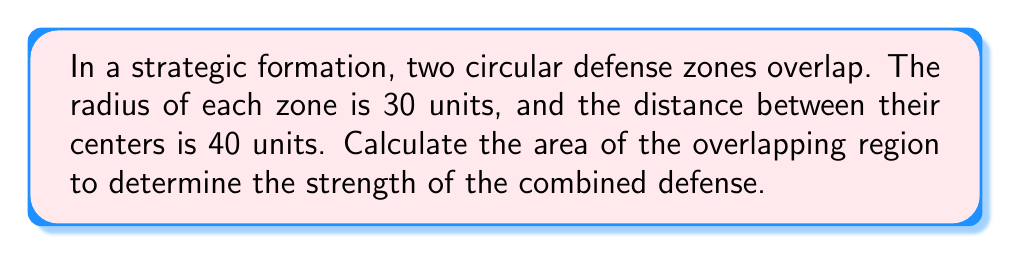Can you solve this math problem? Let's approach this step-by-step:

1) First, we need to recognize that this is a problem involving the intersection of two circles.

2) The area of intersection can be calculated using the formula:

   $$A = 2r^2 \arccos(\frac{d}{2r}) - d\sqrt{r^2 - (\frac{d}{2})^2}$$

   Where $r$ is the radius of each circle and $d$ is the distance between their centers.

3) We're given:
   $r = 30$ units
   $d = 40$ units

4) Let's substitute these values into our formula:

   $$A = 2(30^2) \arccos(\frac{40}{2(30)}) - 40\sqrt{30^2 - (\frac{40}{2})^2}$$

5) Simplify inside the arccos and under the square root:

   $$A = 1800 \arccos(\frac{2}{3}) - 40\sqrt{900 - 400}$$

6) Evaluate:
   $$A = 1800 \arccos(\frac{2}{3}) - 40\sqrt{500}$$

7) Calculate:
   $$A \approx 1800(0.8410686705679303) - 40(22.360679774997898)$$
   $$A \approx 1513.9236070222745 - 894.4271909999159$$
   $$A \approx 619.4964160223586$$

8) Rounding to two decimal places:
   $$A \approx 619.50$$ square units
Answer: $619.50$ square units 